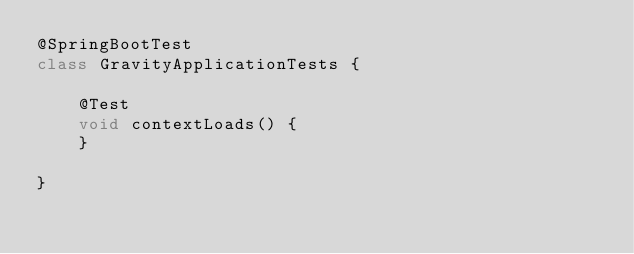<code> <loc_0><loc_0><loc_500><loc_500><_Java_>@SpringBootTest
class GravityApplicationTests {

	@Test
	void contextLoads() {
	}

}
</code> 